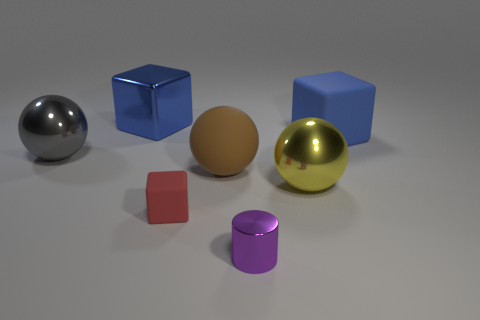Are there any other things that have the same shape as the purple shiny object?
Offer a very short reply. No. There is a ball that is to the right of the blue metallic thing and to the left of the yellow shiny ball; what is its material?
Your response must be concise. Rubber. There is a big ball that is on the left side of the tiny block; what is its color?
Offer a very short reply. Gray. Are there more large brown balls right of the gray shiny thing than cyan rubber objects?
Your answer should be very brief. Yes. What number of other things are there of the same size as the matte sphere?
Give a very brief answer. 4. There is a yellow metal thing; how many big things are behind it?
Make the answer very short. 4. Are there the same number of tiny purple metal objects that are in front of the big blue rubber cube and rubber balls to the left of the rubber sphere?
Give a very brief answer. No. What size is the gray metal object that is the same shape as the brown rubber object?
Your answer should be very brief. Large. There is a tiny thing in front of the small red object; what shape is it?
Your answer should be compact. Cylinder. Is the object right of the big yellow object made of the same material as the small block that is behind the tiny purple cylinder?
Provide a short and direct response. Yes. 